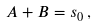<formula> <loc_0><loc_0><loc_500><loc_500>A + B = s _ { 0 } \, ,</formula> 